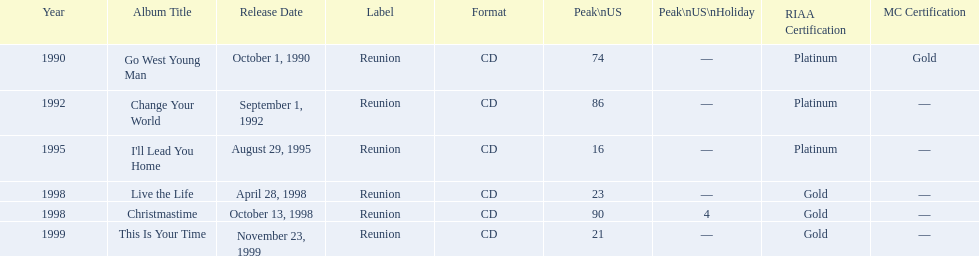Which album has the least peak in the us? I'll Lead You Home. 